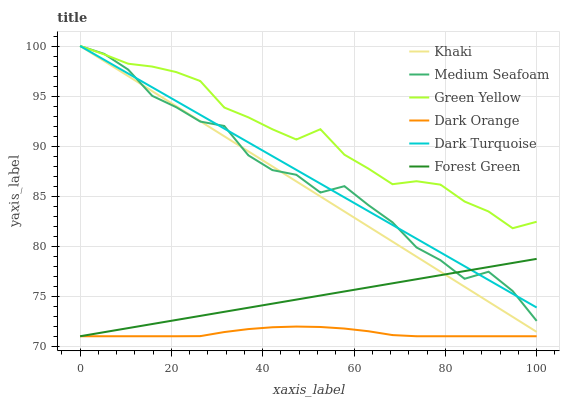Does Khaki have the minimum area under the curve?
Answer yes or no. No. Does Khaki have the maximum area under the curve?
Answer yes or no. No. Is Khaki the smoothest?
Answer yes or no. No. Is Khaki the roughest?
Answer yes or no. No. Does Khaki have the lowest value?
Answer yes or no. No. Does Forest Green have the highest value?
Answer yes or no. No. Is Dark Orange less than Dark Turquoise?
Answer yes or no. Yes. Is Khaki greater than Dark Orange?
Answer yes or no. Yes. Does Dark Orange intersect Dark Turquoise?
Answer yes or no. No. 